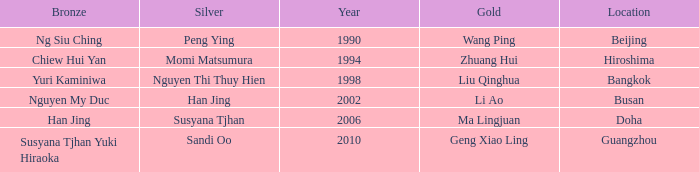What Silver has a Golf of Li AO? Han Jing. 